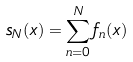<formula> <loc_0><loc_0><loc_500><loc_500>s _ { N } ( x ) = \sum _ { n = 0 } ^ { N } f _ { n } ( x )</formula> 